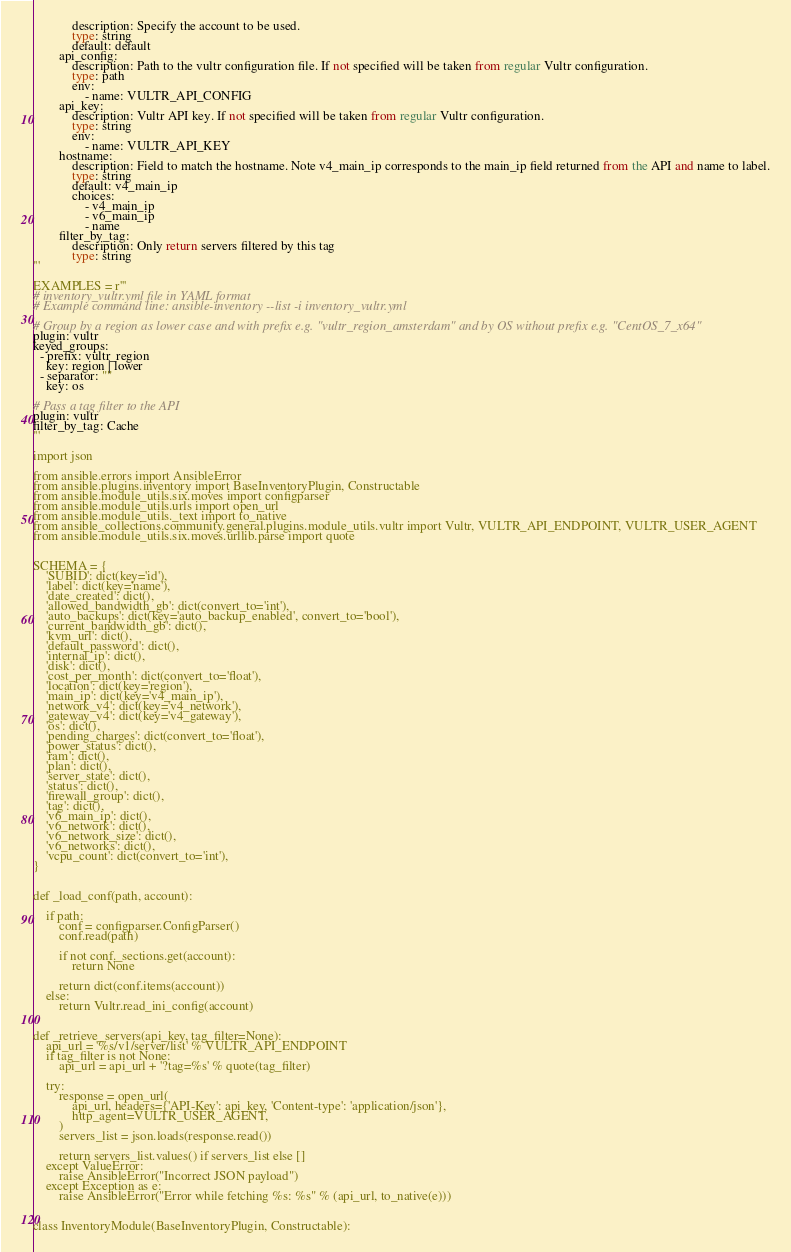Convert code to text. <code><loc_0><loc_0><loc_500><loc_500><_Python_>            description: Specify the account to be used.
            type: string
            default: default
        api_config:
            description: Path to the vultr configuration file. If not specified will be taken from regular Vultr configuration.
            type: path
            env:
                - name: VULTR_API_CONFIG
        api_key:
            description: Vultr API key. If not specified will be taken from regular Vultr configuration.
            type: string
            env:
                - name: VULTR_API_KEY
        hostname:
            description: Field to match the hostname. Note v4_main_ip corresponds to the main_ip field returned from the API and name to label.
            type: string
            default: v4_main_ip
            choices:
                - v4_main_ip
                - v6_main_ip
                - name
        filter_by_tag:
            description: Only return servers filtered by this tag
            type: string
'''

EXAMPLES = r'''
# inventory_vultr.yml file in YAML format
# Example command line: ansible-inventory --list -i inventory_vultr.yml

# Group by a region as lower case and with prefix e.g. "vultr_region_amsterdam" and by OS without prefix e.g. "CentOS_7_x64"
plugin: vultr
keyed_groups:
  - prefix: vultr_region
    key: region | lower
  - separator: ""
    key: os

# Pass a tag filter to the API
plugin: vultr
filter_by_tag: Cache
'''

import json

from ansible.errors import AnsibleError
from ansible.plugins.inventory import BaseInventoryPlugin, Constructable
from ansible.module_utils.six.moves import configparser
from ansible.module_utils.urls import open_url
from ansible.module_utils._text import to_native
from ansible_collections.community.general.plugins.module_utils.vultr import Vultr, VULTR_API_ENDPOINT, VULTR_USER_AGENT
from ansible.module_utils.six.moves.urllib.parse import quote


SCHEMA = {
    'SUBID': dict(key='id'),
    'label': dict(key='name'),
    'date_created': dict(),
    'allowed_bandwidth_gb': dict(convert_to='int'),
    'auto_backups': dict(key='auto_backup_enabled', convert_to='bool'),
    'current_bandwidth_gb': dict(),
    'kvm_url': dict(),
    'default_password': dict(),
    'internal_ip': dict(),
    'disk': dict(),
    'cost_per_month': dict(convert_to='float'),
    'location': dict(key='region'),
    'main_ip': dict(key='v4_main_ip'),
    'network_v4': dict(key='v4_network'),
    'gateway_v4': dict(key='v4_gateway'),
    'os': dict(),
    'pending_charges': dict(convert_to='float'),
    'power_status': dict(),
    'ram': dict(),
    'plan': dict(),
    'server_state': dict(),
    'status': dict(),
    'firewall_group': dict(),
    'tag': dict(),
    'v6_main_ip': dict(),
    'v6_network': dict(),
    'v6_network_size': dict(),
    'v6_networks': dict(),
    'vcpu_count': dict(convert_to='int'),
}


def _load_conf(path, account):

    if path:
        conf = configparser.ConfigParser()
        conf.read(path)

        if not conf._sections.get(account):
            return None

        return dict(conf.items(account))
    else:
        return Vultr.read_ini_config(account)


def _retrieve_servers(api_key, tag_filter=None):
    api_url = '%s/v1/server/list' % VULTR_API_ENDPOINT
    if tag_filter is not None:
        api_url = api_url + '?tag=%s' % quote(tag_filter)

    try:
        response = open_url(
            api_url, headers={'API-Key': api_key, 'Content-type': 'application/json'},
            http_agent=VULTR_USER_AGENT,
        )
        servers_list = json.loads(response.read())

        return servers_list.values() if servers_list else []
    except ValueError:
        raise AnsibleError("Incorrect JSON payload")
    except Exception as e:
        raise AnsibleError("Error while fetching %s: %s" % (api_url, to_native(e)))


class InventoryModule(BaseInventoryPlugin, Constructable):
</code> 